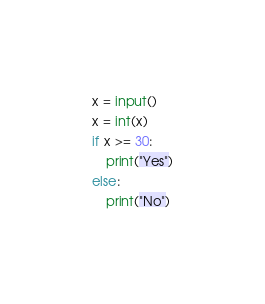Convert code to text. <code><loc_0><loc_0><loc_500><loc_500><_Python_>x = input()
x = int(x)
if x >= 30:
    print("Yes")
else:
    print("No")
</code> 